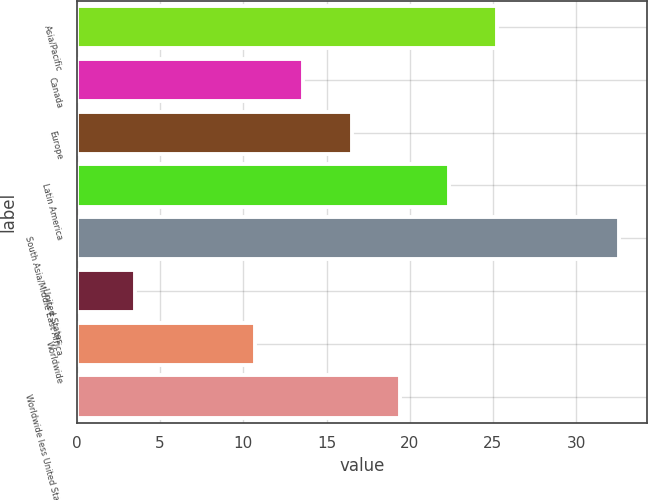Convert chart. <chart><loc_0><loc_0><loc_500><loc_500><bar_chart><fcel>Asia/Pacific<fcel>Canada<fcel>Europe<fcel>Latin America<fcel>South Asia/Middle East Africa<fcel>United States<fcel>Worldwide<fcel>Worldwide less United States<nl><fcel>25.25<fcel>13.61<fcel>16.52<fcel>22.34<fcel>32.6<fcel>3.5<fcel>10.7<fcel>19.43<nl></chart> 